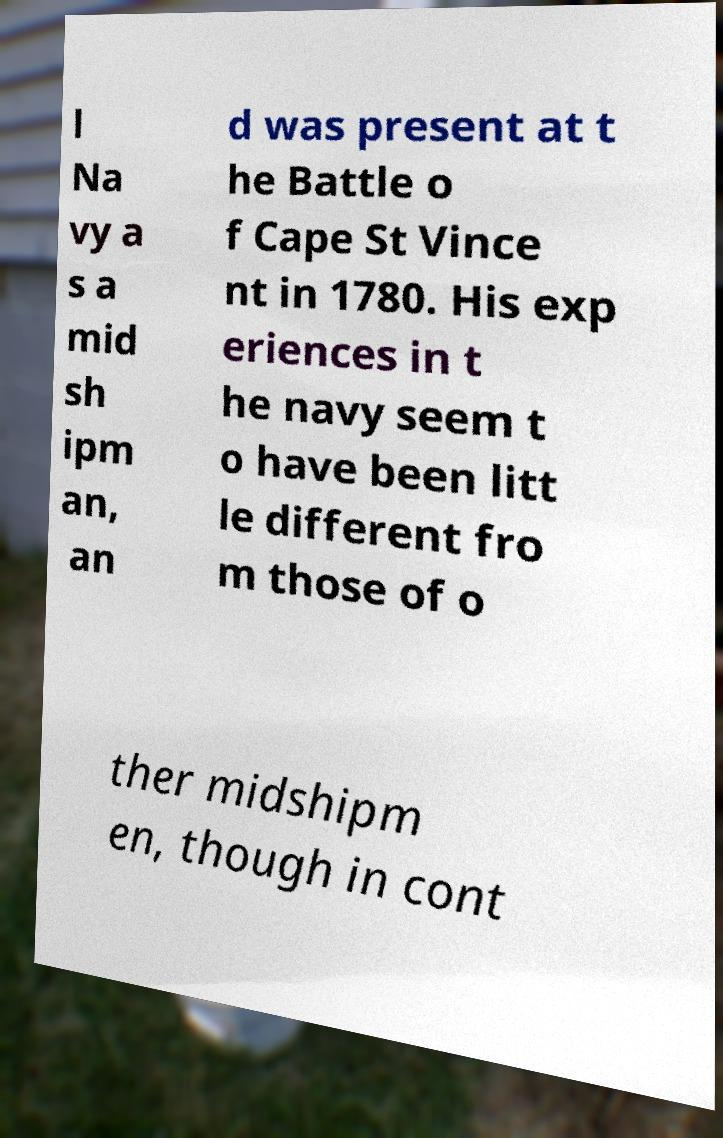I need the written content from this picture converted into text. Can you do that? l Na vy a s a mid sh ipm an, an d was present at t he Battle o f Cape St Vince nt in 1780. His exp eriences in t he navy seem t o have been litt le different fro m those of o ther midshipm en, though in cont 